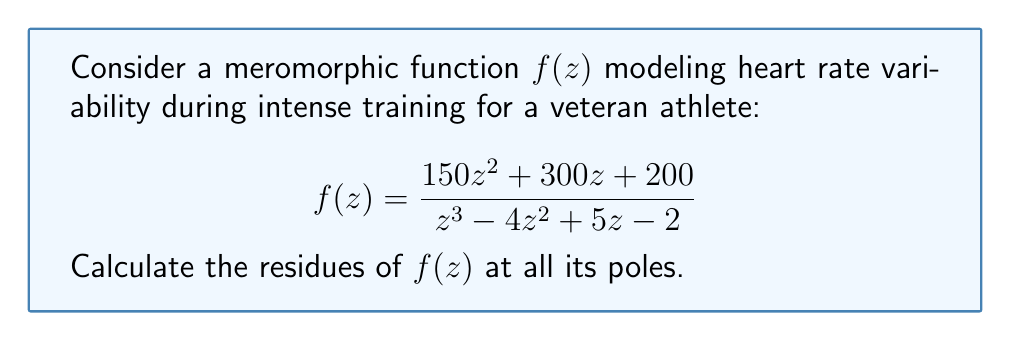Can you solve this math problem? 1) First, we need to find the poles of $f(z)$. The poles are the roots of the denominator:

   $z^3 - 4z^2 + 5z - 2 = 0$

2) This cubic equation can be factored as:

   $(z - 1)(z^2 - 3z + 2) = (z - 1)(z - 1)(z - 2) = 0$

   So, the poles are at $z = 1$ (double pole) and $z = 2$ (simple pole).

3) For the simple pole at $z = 2$, we can use the formula:

   $\text{Res}(f, 2) = \lim_{z \to 2} (z - 2)f(z)$

   $= \lim_{z \to 2} \frac{(z - 2)(150z^2 + 300z + 200)}{(z - 1)^2(z - 2)}$
   
   $= \lim_{z \to 2} \frac{150z^2 + 300z + 200}{(z - 1)^2}$
   
   $= \frac{150(2)^2 + 300(2) + 200}{(2 - 1)^2} = \frac{1000}{1} = 1000$

4) For the double pole at $z = 1$, we use the formula for a pole of order 2:

   $\text{Res}(f, 1) = \lim_{z \to 1} \frac{d}{dz}[(z - 1)^2f(z)]$

5) Let $g(z) = (z - 1)^2f(z) = \frac{(z - 1)^2(150z^2 + 300z + 200)}{(z - 1)^2(z - 2)}$

   $g(z) = \frac{150z^2 + 300z + 200}{z - 2}$

6) Now we differentiate $g(z)$:

   $g'(z) = \frac{(300z + 300)(z - 2) - (150z^2 + 300z + 200)}{(z - 2)^2}$

7) Evaluate the limit:

   $\text{Res}(f, 1) = \lim_{z \to 1} g'(z) = \frac{600 - 650}{1} = -50$

Therefore, the residues are 1000 at $z = 2$ and -50 at $z = 1$.
Answer: $\text{Res}(f, 2) = 1000$, $\text{Res}(f, 1) = -50$ 